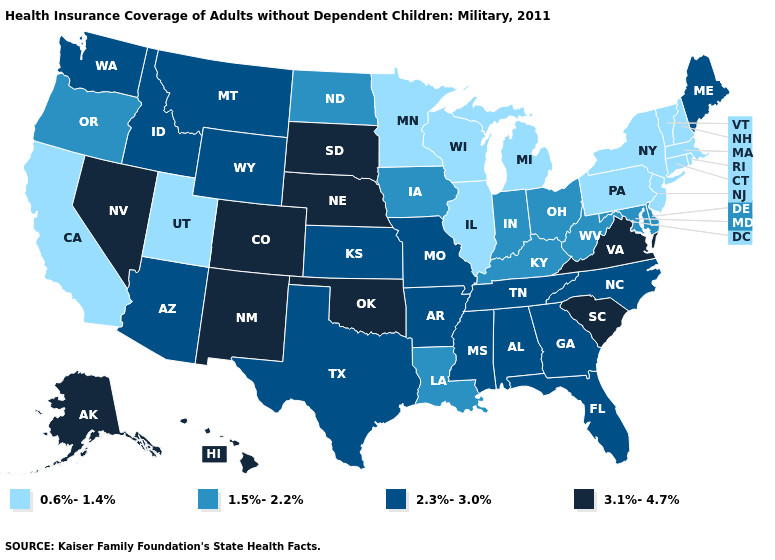Does the first symbol in the legend represent the smallest category?
Answer briefly. Yes. Does New Mexico have the highest value in the USA?
Be succinct. Yes. What is the lowest value in the USA?
Concise answer only. 0.6%-1.4%. Which states have the highest value in the USA?
Answer briefly. Alaska, Colorado, Hawaii, Nebraska, Nevada, New Mexico, Oklahoma, South Carolina, South Dakota, Virginia. Which states have the lowest value in the MidWest?
Write a very short answer. Illinois, Michigan, Minnesota, Wisconsin. Name the states that have a value in the range 0.6%-1.4%?
Keep it brief. California, Connecticut, Illinois, Massachusetts, Michigan, Minnesota, New Hampshire, New Jersey, New York, Pennsylvania, Rhode Island, Utah, Vermont, Wisconsin. Does the first symbol in the legend represent the smallest category?
Answer briefly. Yes. How many symbols are there in the legend?
Answer briefly. 4. Does Tennessee have a higher value than Virginia?
Answer briefly. No. Does South Dakota have the highest value in the USA?
Answer briefly. Yes. Does Kentucky have the lowest value in the USA?
Quick response, please. No. Among the states that border Mississippi , which have the highest value?
Answer briefly. Alabama, Arkansas, Tennessee. Is the legend a continuous bar?
Answer briefly. No. Does Texas have the lowest value in the South?
Quick response, please. No. 